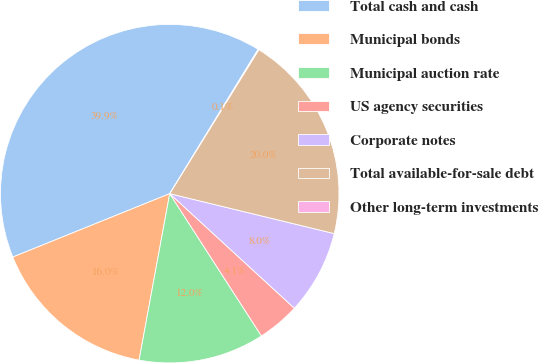Convert chart to OTSL. <chart><loc_0><loc_0><loc_500><loc_500><pie_chart><fcel>Total cash and cash<fcel>Municipal bonds<fcel>Municipal auction rate<fcel>US agency securities<fcel>Corporate notes<fcel>Total available-for-sale debt<fcel>Other long-term investments<nl><fcel>39.86%<fcel>15.99%<fcel>12.01%<fcel>4.06%<fcel>8.04%<fcel>19.97%<fcel>0.08%<nl></chart> 